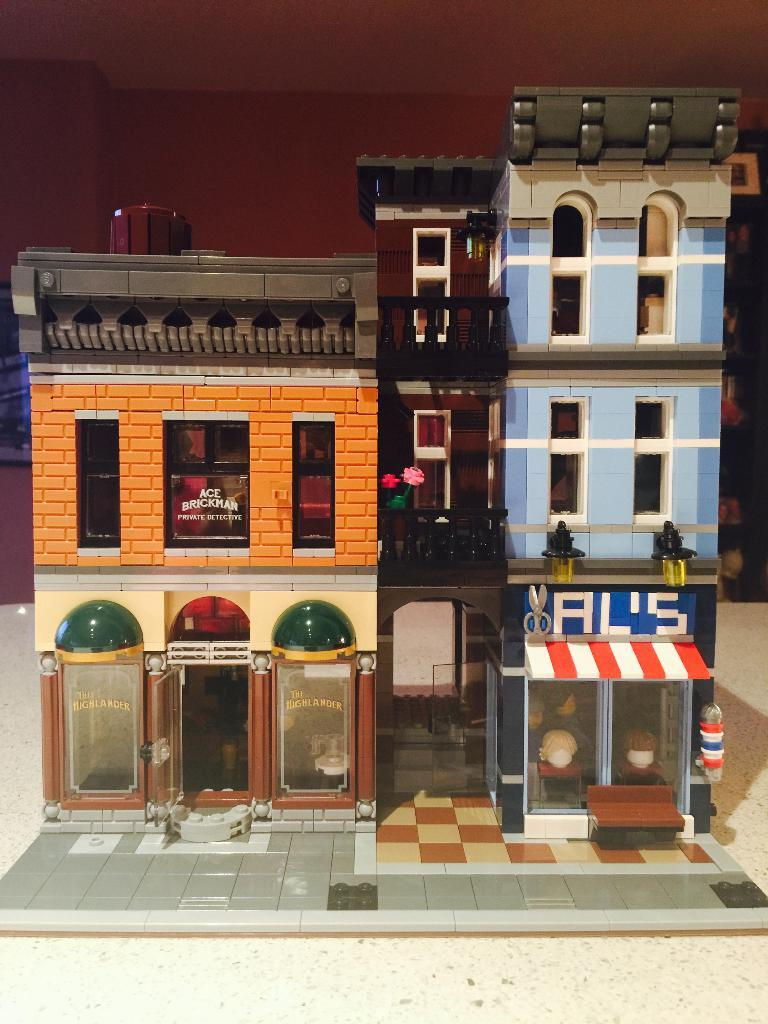What is the main subject of the image? The main subject of the image is a miniature house. Can you describe the appearance of the miniature house? The miniature house is colorful. What is the color of the surface on which the miniature house is placed? The miniature house is on a cream-colored surface. What can be seen in the background of the image? There is a maroon-colored wall in the background of the image. How does the miniature house show respect to the brick wall in the image? There is no brick wall present in the image, and the miniature house does not show respect or interact with any other objects in the image. 